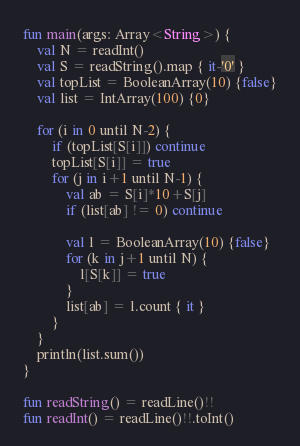<code> <loc_0><loc_0><loc_500><loc_500><_Kotlin_>fun main(args: Array<String>) {
    val N = readInt()
    val S = readString().map { it-'0' }
    val topList = BooleanArray(10) {false}
    val list = IntArray(100) {0}

    for (i in 0 until N-2) {
        if (topList[S[i]]) continue
        topList[S[i]] = true
        for (j in i+1 until N-1) {
            val ab = S[i]*10+S[j]
            if (list[ab] != 0) continue

            val l = BooleanArray(10) {false}
            for (k in j+1 until N) {
                l[S[k]] = true
            }
            list[ab] = l.count { it }
        }
    }
    println(list.sum())
}

fun readString() = readLine()!!
fun readInt() = readLine()!!.toInt()</code> 